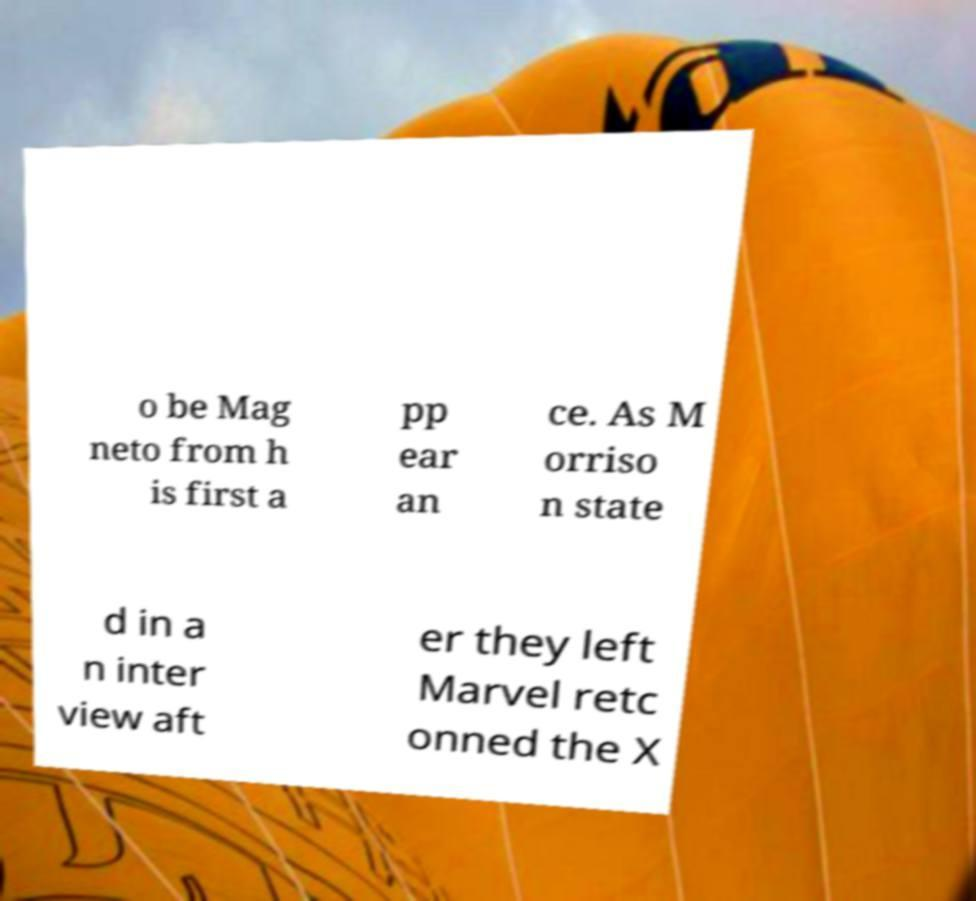Please identify and transcribe the text found in this image. o be Mag neto from h is first a pp ear an ce. As M orriso n state d in a n inter view aft er they left Marvel retc onned the X 